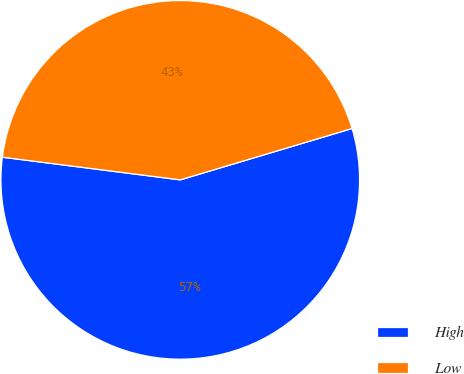Convert chart to OTSL. <chart><loc_0><loc_0><loc_500><loc_500><pie_chart><fcel>High<fcel>Low<nl><fcel>56.64%<fcel>43.36%<nl></chart> 